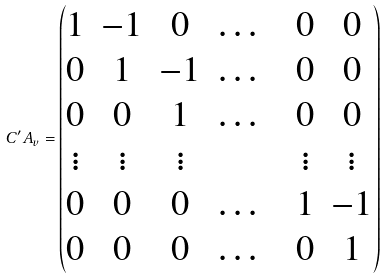Convert formula to latex. <formula><loc_0><loc_0><loc_500><loc_500>C ^ { \prime } A _ { v } = \begin{pmatrix} 1 & - 1 & 0 & \dots & & 0 & 0 \\ 0 & 1 & - 1 & \dots & & 0 & 0 \\ 0 & 0 & 1 & \dots & & 0 & 0 \\ \vdots & \vdots & \vdots & & & \vdots & \vdots \\ 0 & 0 & 0 & \dots & & 1 & - 1 \\ 0 & 0 & 0 & \dots & & 0 & 1 \end{pmatrix}</formula> 